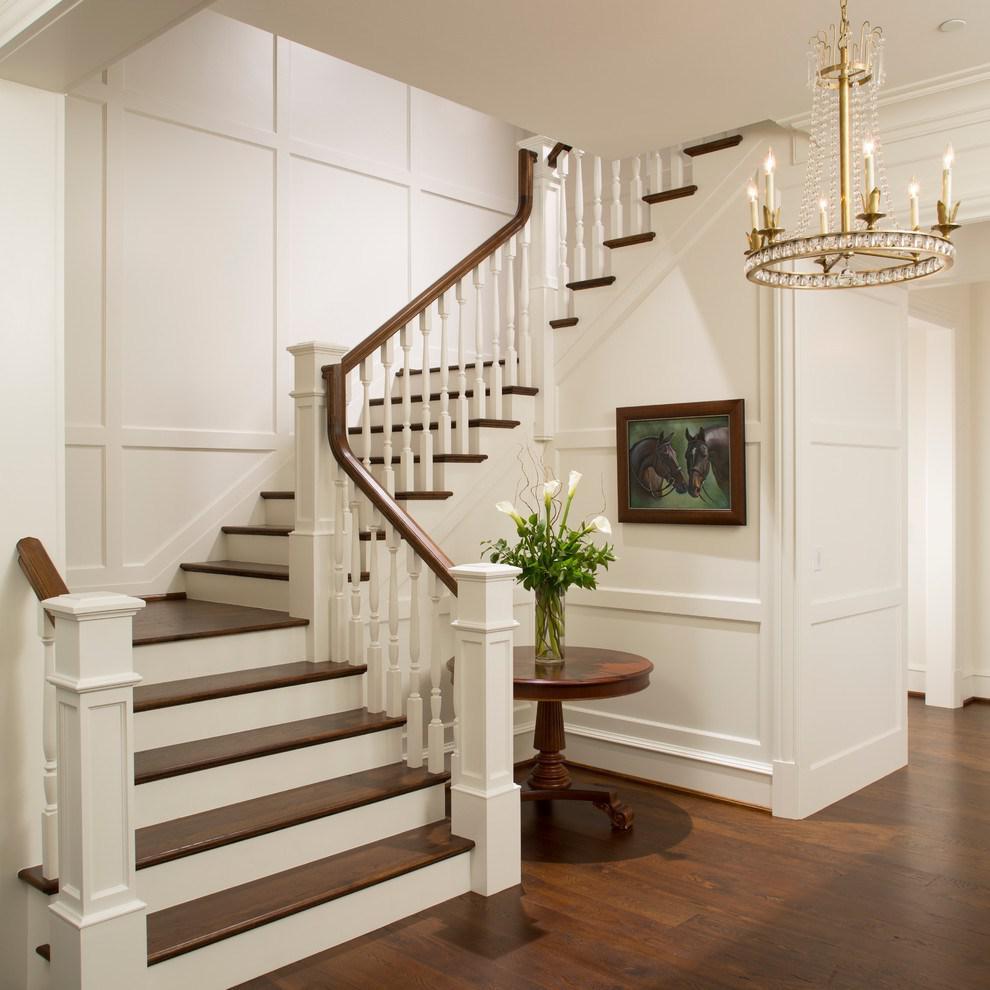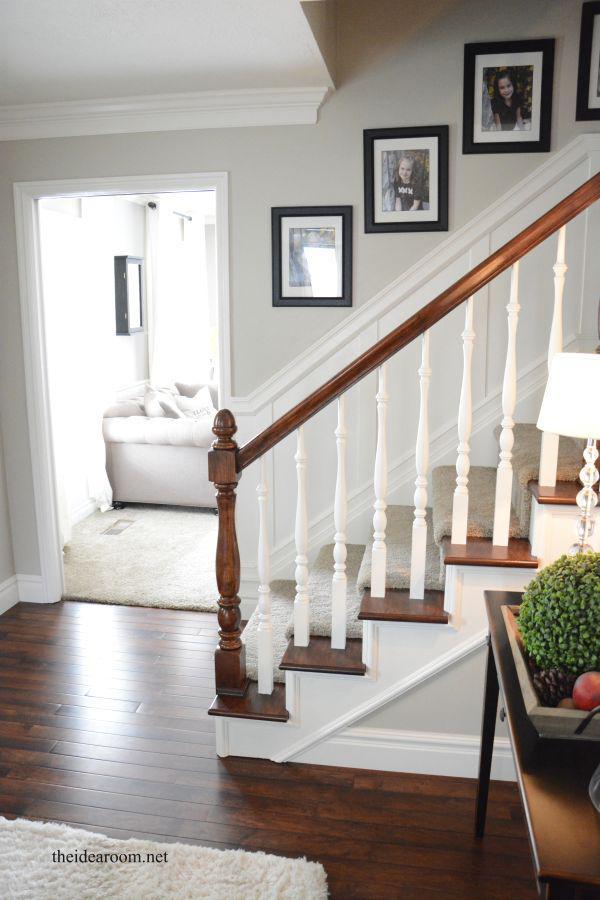The first image is the image on the left, the second image is the image on the right. Assess this claim about the two images: "Framed pictures follow the line of the stairway in the image on the right.". Correct or not? Answer yes or no. Yes. The first image is the image on the left, the second image is the image on the right. Given the left and right images, does the statement "In at least one of the images, the piece of furniture near the bottom of the stairs has a vase of flowers on it." hold true? Answer yes or no. Yes. 